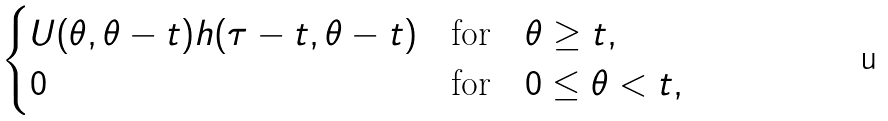Convert formula to latex. <formula><loc_0><loc_0><loc_500><loc_500>\begin{cases} U ( \theta , \theta - t ) h ( \tau - t , \theta - t ) & \text {for} \quad \theta \geq t , \\ 0 & \text {for} \quad 0 \leq \theta < t , \end{cases}</formula> 